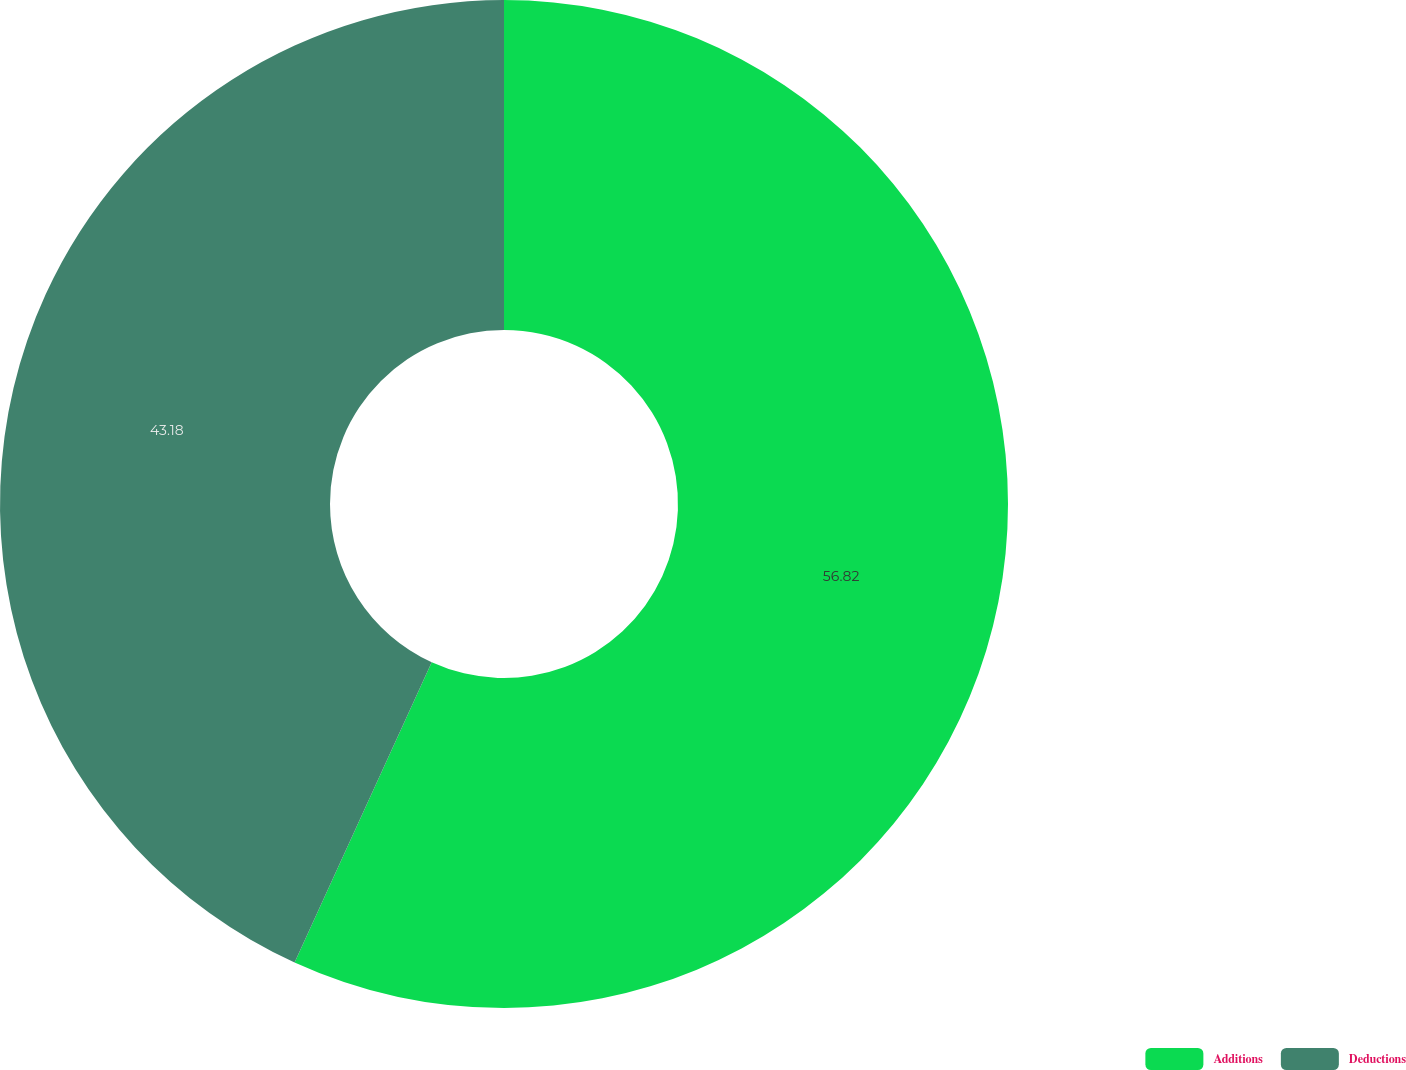Convert chart to OTSL. <chart><loc_0><loc_0><loc_500><loc_500><pie_chart><fcel>Additions<fcel>Deductions<nl><fcel>56.82%<fcel>43.18%<nl></chart> 